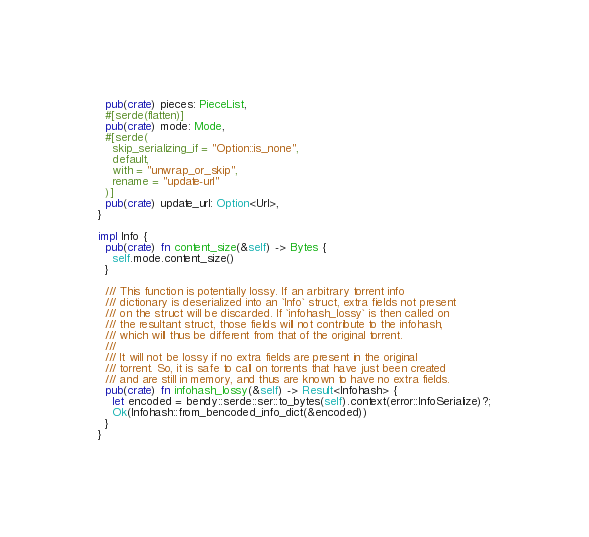<code> <loc_0><loc_0><loc_500><loc_500><_Rust_>  pub(crate) pieces: PieceList,
  #[serde(flatten)]
  pub(crate) mode: Mode,
  #[serde(
    skip_serializing_if = "Option::is_none",
    default,
    with = "unwrap_or_skip",
    rename = "update-url"
  )]
  pub(crate) update_url: Option<Url>,
}

impl Info {
  pub(crate) fn content_size(&self) -> Bytes {
    self.mode.content_size()
  }

  /// This function is potentially lossy. If an arbitrary torrent info
  /// dictionary is deserialized into an `Info` struct, extra fields not present
  /// on the struct will be discarded. If `infohash_lossy` is then called on
  /// the resultant struct, those fields will not contribute to the infohash,
  /// which will thus be different from that of the original torrent.
  ///
  /// It will not be lossy if no extra fields are present in the original
  /// torrent. So, it is safe to call on torrents that have just been created
  /// and are still in memory, and thus are known to have no extra fields.
  pub(crate) fn infohash_lossy(&self) -> Result<Infohash> {
    let encoded = bendy::serde::ser::to_bytes(self).context(error::InfoSerialize)?;
    Ok(Infohash::from_bencoded_info_dict(&encoded))
  }
}
</code> 